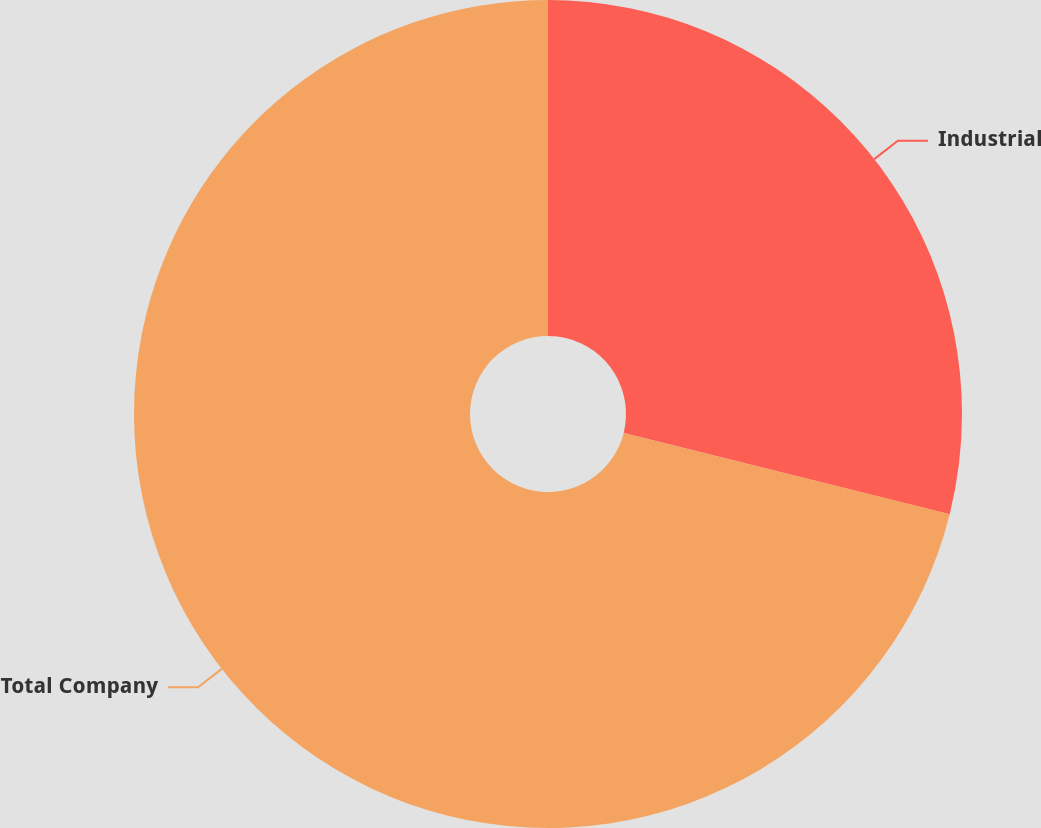<chart> <loc_0><loc_0><loc_500><loc_500><pie_chart><fcel>Industrial<fcel>Total Company<nl><fcel>28.89%<fcel>71.11%<nl></chart> 